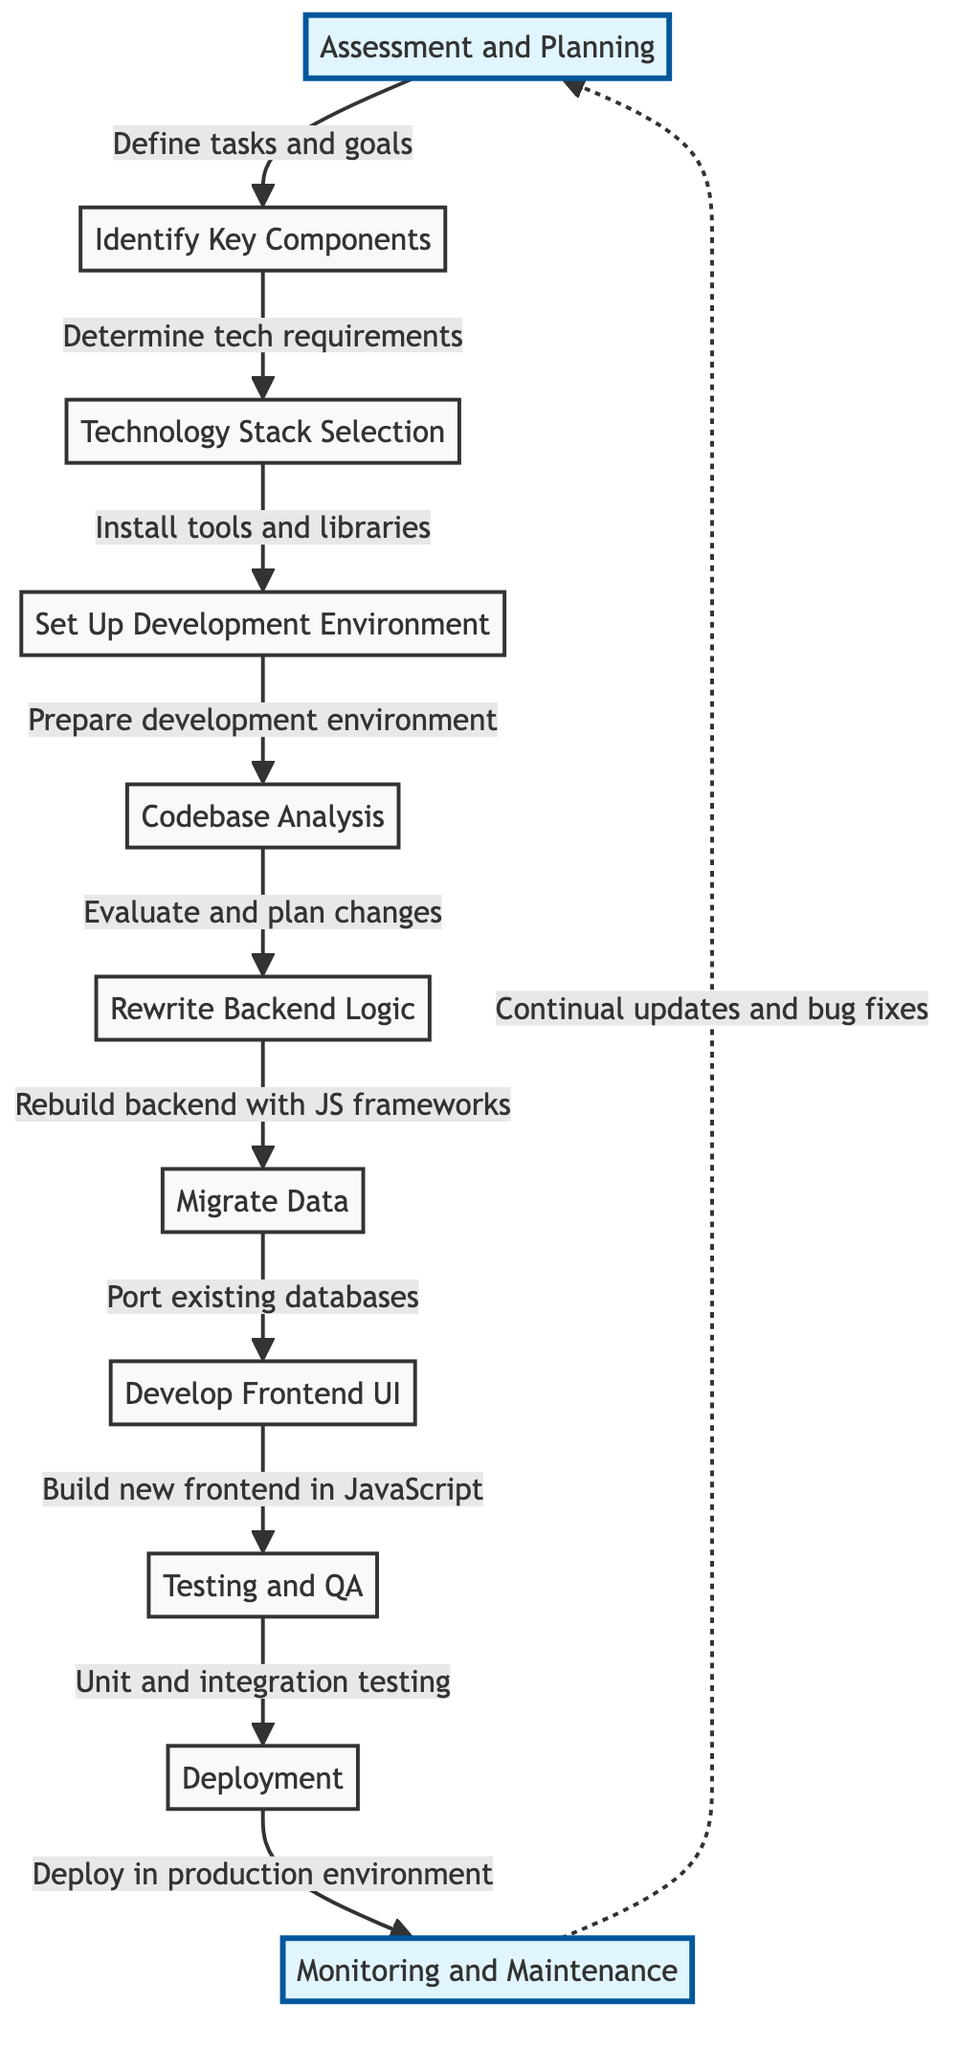What is the first step in the migration workflow? The first step in the workflow is depicted as "Assessment and Planning," which initiates the entire migration process.
Answer: Assessment and Planning How many total steps are there in the migration workflow? Counting all the nodes from the diagram, there are eleven distinct steps presented for the migration process.
Answer: Eleven What is the last step indicated in the migration process? The diagram indicates that the final step is "Monitoring and Maintenance," which concludes the workflow.
Answer: Monitoring and Maintenance Which step follows "Codebase Analysis"? The diagram shows that "Rewrite Backend Logic" is the step that immediately follows "Codebase Analysis," indicating a sequential transition in the process.
Answer: Rewrite Backend Logic In which step is the backend logic rebuilt using JS frameworks? According to the diagram, this happens in the step labeled "Rewrite Backend Logic," which specifically instructs on rebuilding the backend for JavaScript compatibility.
Answer: Rewrite Backend Logic What relationship exists between "Testing and QA" and "Deployment"? The diagram illustrates that "Testing and QA" precedes "Deployment," implying that testing must be completed before deploying to a production environment.
Answer: "Testing and QA" leads to "Deployment" What task is associated with "Migrate Data"? The diagram connects "Migrate Data" with the action to "Port existing databases," indicating that this step involves managing the transition of databases.
Answer: Port existing databases Which node serves as a feedback loop in the workflow? The diagram indicates a feedback loop from "Monitoring and Maintenance" back to "Assessment and Planning," emphasizing continuous improvement post-deployment.
Answer: Assessment and Planning What action occurs directly after "Develop Frontend UI"? The subsequent action following "Develop Frontend UI" is "Testing and QA," demonstrating the workflow's regular sequence of developing and testing components.
Answer: Testing and QA 